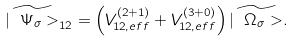Convert formula to latex. <formula><loc_0><loc_0><loc_500><loc_500>\widetilde { | \ \Psi _ { \sigma } > } _ { 1 2 } = \left ( V ^ { ( 2 + 1 ) } _ { 1 2 , e f f } + V ^ { ( 3 + 0 ) } _ { 1 2 , e f f } \right ) \widetilde { | \ \Omega _ { \sigma } > } .</formula> 